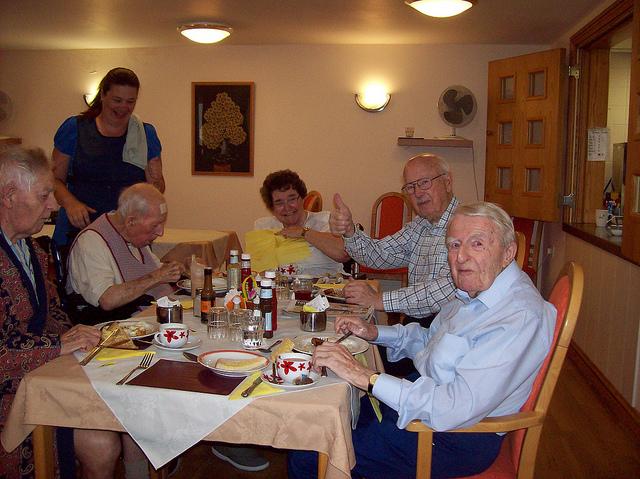Are these men in a kitchen?
Short answer required. No. Is this a family gathering?
Concise answer only. Yes. Are these high school seniors eating lunch?
Quick response, please. No. How many squares are on the door by the fan?
Short answer required. 6. How many people are standing?
Be succinct. 1. 